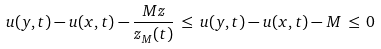<formula> <loc_0><loc_0><loc_500><loc_500>u ( y , t ) - u ( x , t ) - \frac { M z } { z _ { M } ( t ) } \, \leq \, u ( y , t ) - u ( x , t ) - M \, \leq \, 0</formula> 